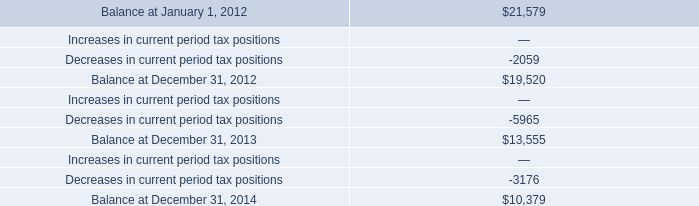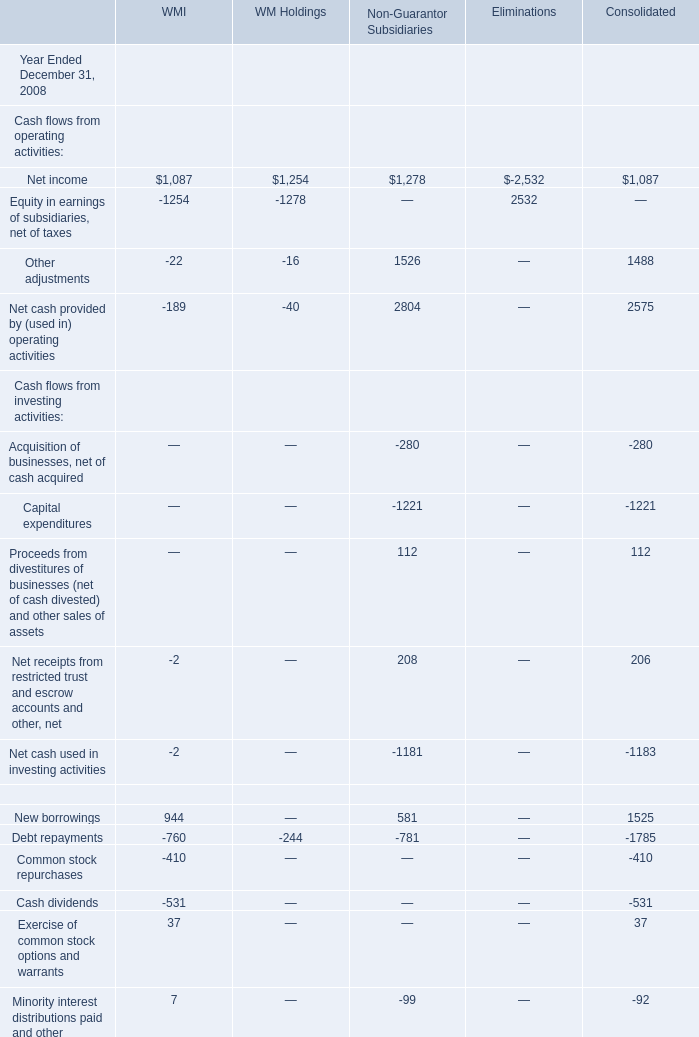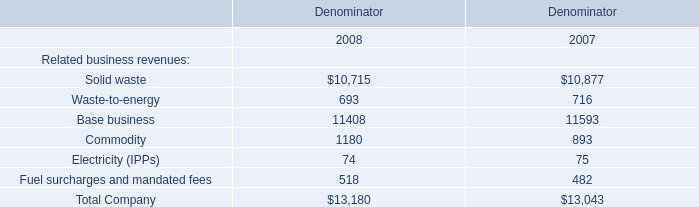For which year Ended December 31 is Net income in terms of Cash flows from operating activities for Non-Guarantor Subsidiaries smaller than 1300? 
Answer: 2008. What's the growth rate of Net income in terms of Cash flows from operating activities for Non-Guarantor Subsidiaries in 2008 Ended December 31? 
Computations: ((1278 - 1389) / 1389)
Answer: -0.07991. 